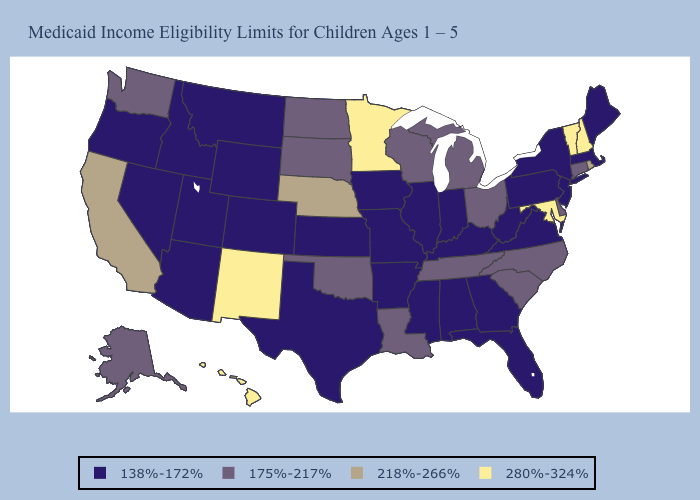What is the highest value in the MidWest ?
Keep it brief. 280%-324%. Does New York have the highest value in the USA?
Concise answer only. No. What is the value of Colorado?
Answer briefly. 138%-172%. What is the highest value in states that border Virginia?
Answer briefly. 280%-324%. What is the highest value in states that border Utah?
Answer briefly. 280%-324%. Does Maine have the lowest value in the USA?
Keep it brief. Yes. Among the states that border Wyoming , which have the lowest value?
Short answer required. Colorado, Idaho, Montana, Utah. Among the states that border Connecticut , which have the lowest value?
Short answer required. Massachusetts, New York. Does Alaska have the lowest value in the West?
Write a very short answer. No. What is the value of Oregon?
Give a very brief answer. 138%-172%. Is the legend a continuous bar?
Concise answer only. No. What is the value of Virginia?
Quick response, please. 138%-172%. Among the states that border Kansas , does Oklahoma have the lowest value?
Write a very short answer. No. Name the states that have a value in the range 280%-324%?
Be succinct. Hawaii, Maryland, Minnesota, New Hampshire, New Mexico, Vermont. What is the value of Oklahoma?
Write a very short answer. 175%-217%. 